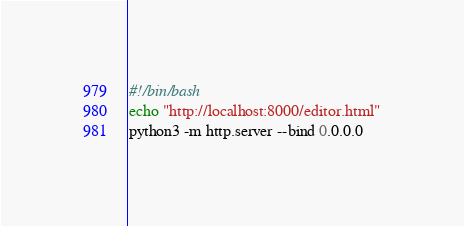Convert code to text. <code><loc_0><loc_0><loc_500><loc_500><_Bash_>#!/bin/bash
echo "http://localhost:8000/editor.html"
python3 -m http.server --bind 0.0.0.0
</code> 